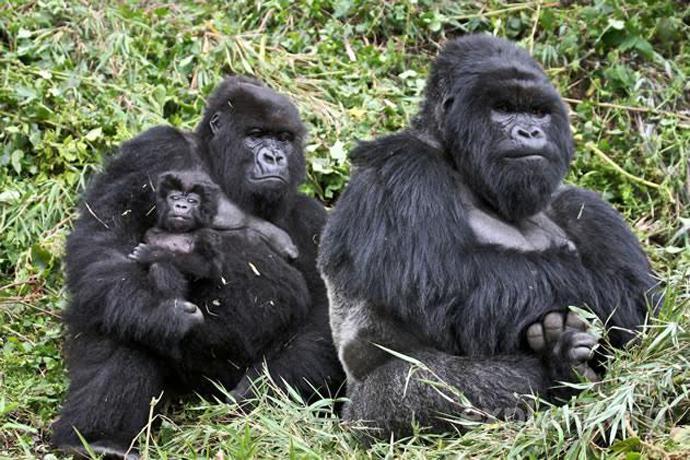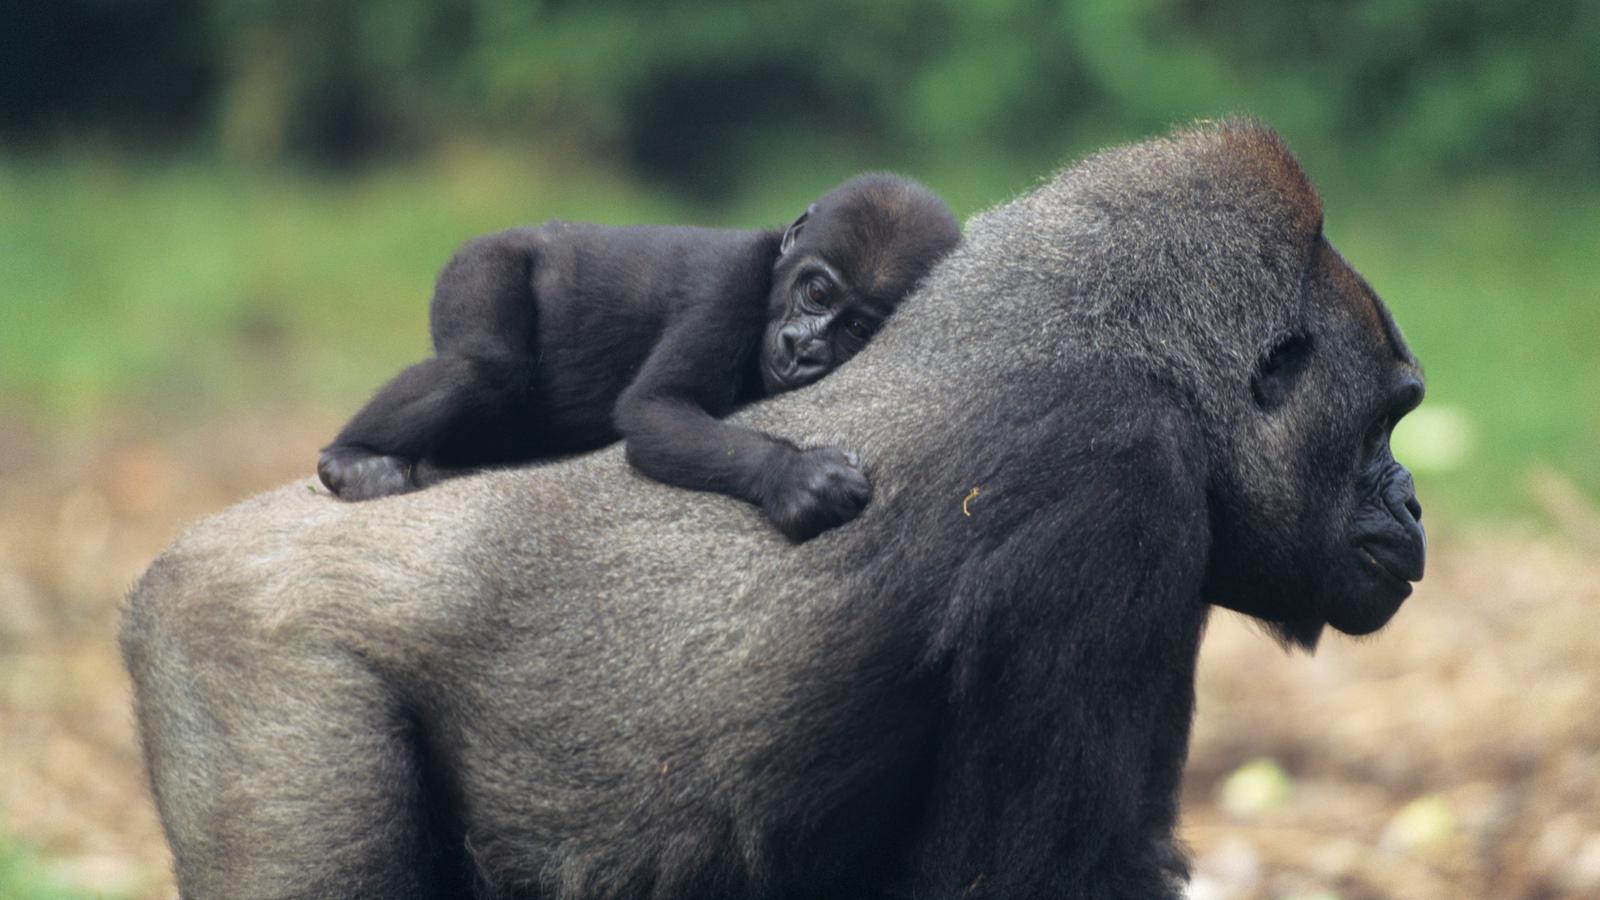The first image is the image on the left, the second image is the image on the right. Evaluate the accuracy of this statement regarding the images: "There are no more than four monkeys.". Is it true? Answer yes or no. No. The first image is the image on the left, the second image is the image on the right. Evaluate the accuracy of this statement regarding the images: "There are no more than two baby gorillas in both images.". Is it true? Answer yes or no. Yes. 